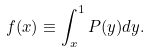Convert formula to latex. <formula><loc_0><loc_0><loc_500><loc_500>f ( x ) \equiv \int _ { x } ^ { 1 } P ( y ) d y .</formula> 